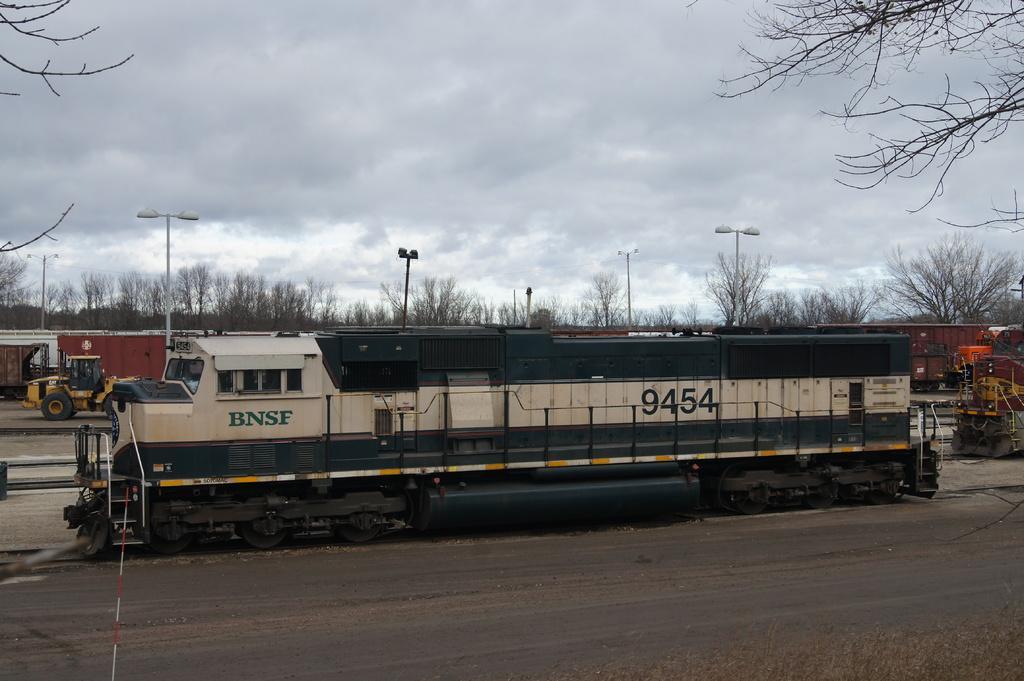In one or two sentences, can you explain what this image depicts? In this image we can see the train is moving on the railway track. In the background, we can see a bulldozer, a few more trains, trees, light poles and the cloudy sky. 